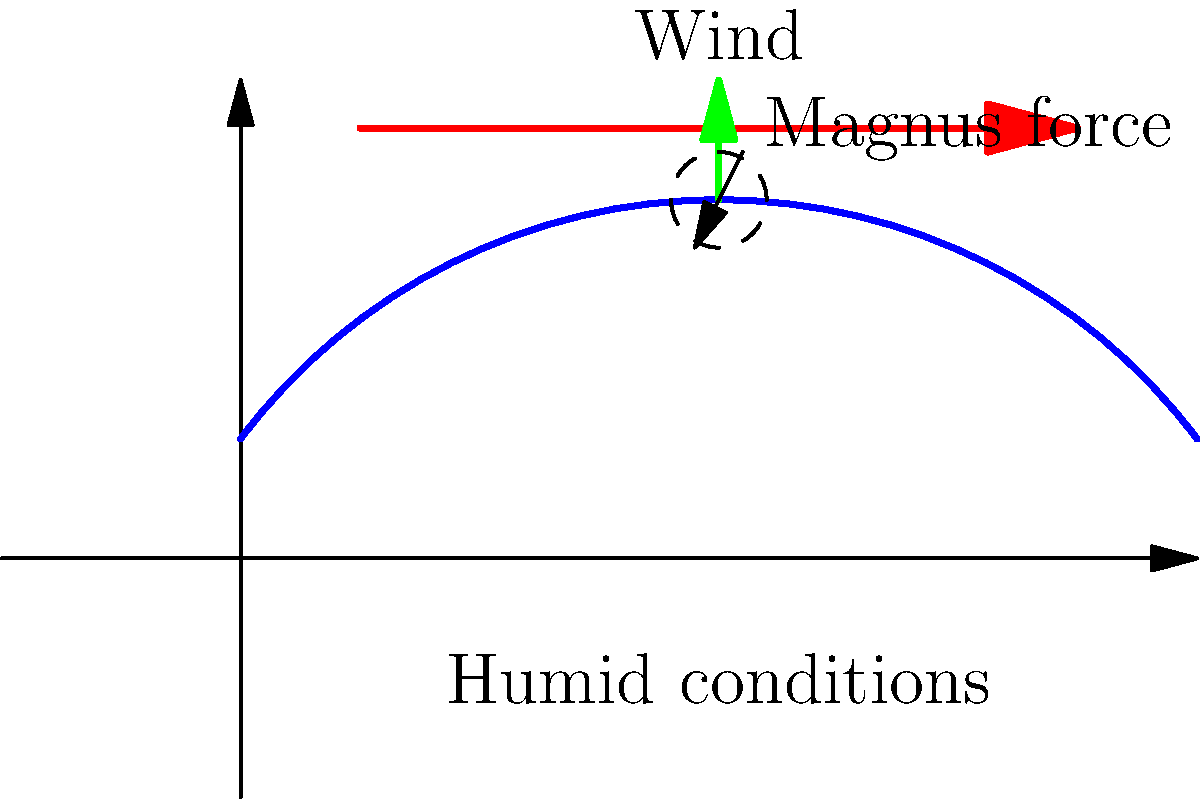In the diagram illustrating the Magnus effect on a cricket ball's swing in humid conditions, what is the primary factor causing the ball to deviate from its expected path, and how does this effect differ in dry conditions? To understand the Magnus effect on a cricket ball's swing in different weather conditions, let's break it down step-by-step:

1. Magnus effect: This is the phenomenon where a spinning object in a fluid creates a whirlpool of fluid around it, exerting a force perpendicular to the line of motion.

2. In the diagram:
   - The blue curve represents the ball's trajectory.
   - The red arrow shows the wind direction.
   - The green arrow indicates the Magnus force.
   - The dashed circle with an arrow shows the ball's rotation.

3. Humid conditions (as shown in the diagram):
   - Air is denser due to water vapor content.
   - The cricket ball's seam interacts more with the humid air.
   - This interaction enhances the pressure difference between the two sides of the ball.

4. Magnus force in humid conditions:
   - The enhanced pressure difference results in a stronger Magnus force.
   - This force causes the ball to swing more, deviating significantly from its expected path.

5. Dry conditions (not shown in the diagram):
   - Air is less dense.
   - The interaction between the ball's seam and the air is reduced.
   - The pressure difference is less pronounced.
   - The Magnus force is weaker, resulting in less swing.

6. Primary factor:
   - The primary factor causing the deviation is the enhanced Magnus force due to the interaction between the ball's seam and the humid air.

7. Difference in dry conditions:
   - In dry conditions, the Magnus effect is less pronounced.
   - The ball would swing less and follow a path closer to its expected trajectory.

The key difference lies in the strength of the Magnus force, which is greater in humid conditions due to increased air density and enhanced seam-air interaction.
Answer: Enhanced Magnus force due to increased air density and seam-air interaction in humid conditions; less pronounced effect in dry conditions. 